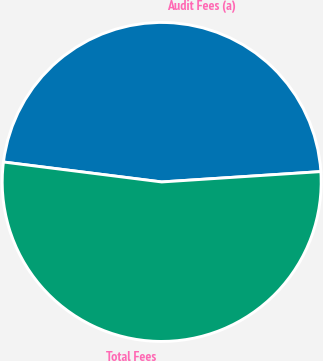Convert chart. <chart><loc_0><loc_0><loc_500><loc_500><pie_chart><fcel>Audit Fees (a)<fcel>Total Fees<nl><fcel>46.97%<fcel>53.03%<nl></chart> 